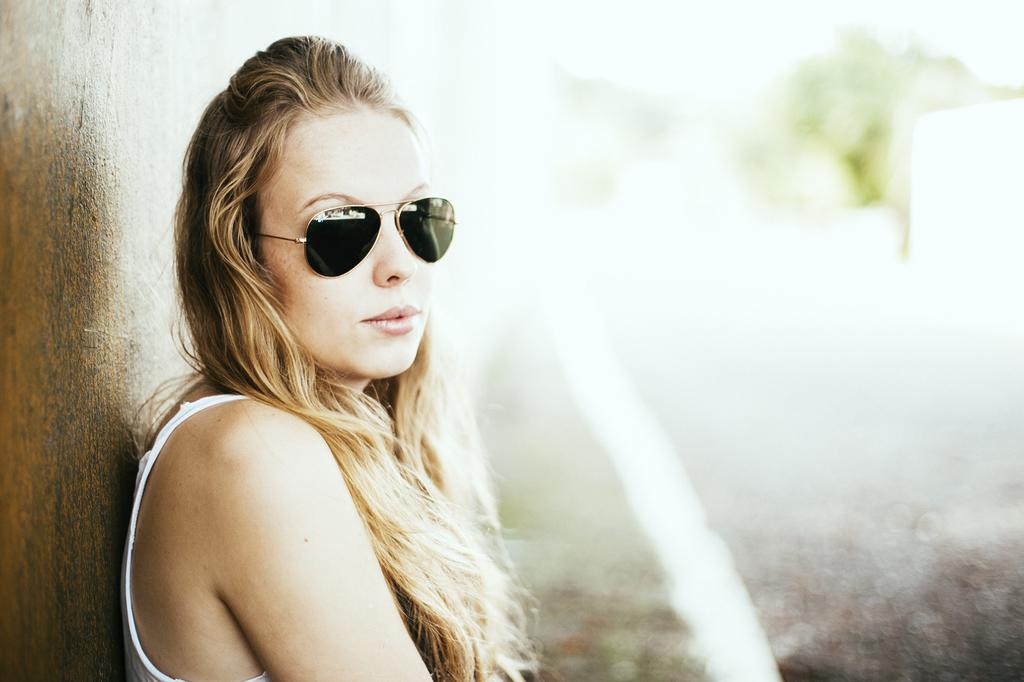Who is present in the image? There is a woman in the image. What is the woman wearing? The woman is wearing clothes and goggles. What can be seen in the background of the image? The background of the image is blurred. What type of soup is the woman offering in the image? There is no soup present in the image. What advice is the woman giving to the person in the image? There is no indication of a conversation or advice-giving in the image. 